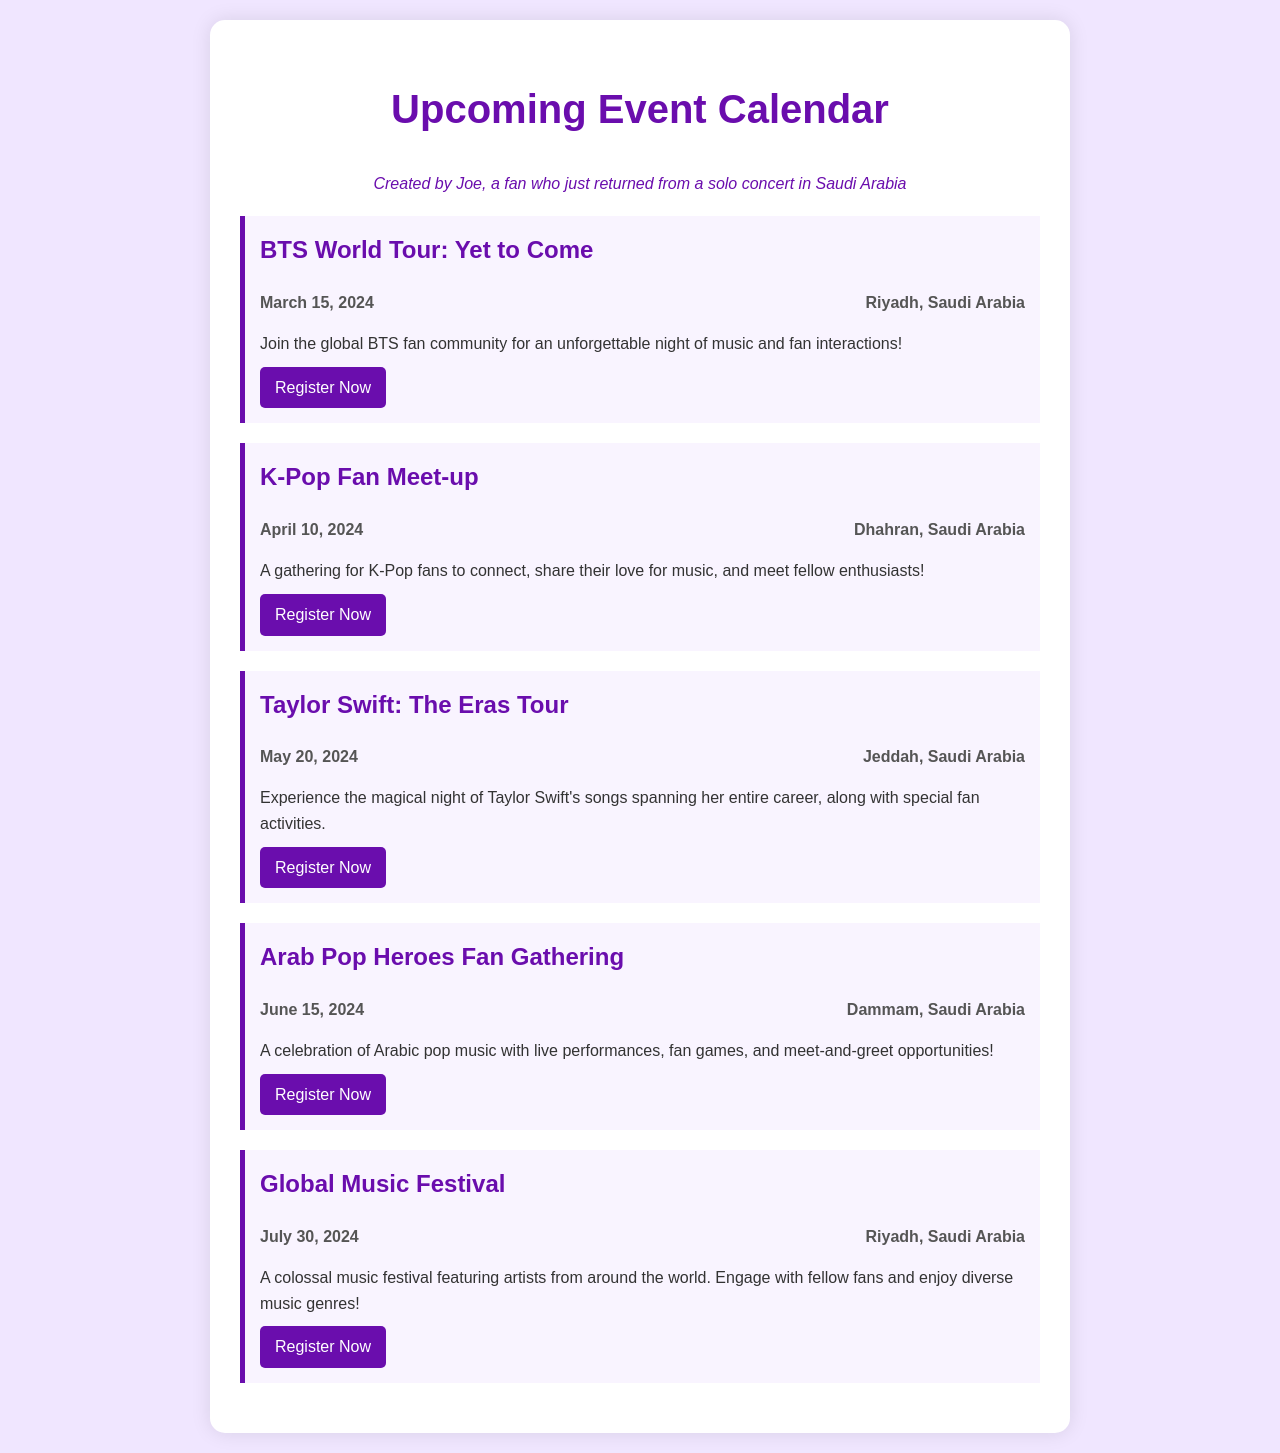What is the title of the first event? The first event listed is "BTS World Tour: Yet to Come."
Answer: BTS World Tour: Yet to Come When is Taylor Swift's concert scheduled? The scheduled date for Taylor Swift's concert is May 20, 2024.
Answer: May 20, 2024 Where will the K-Pop Fan Meet-up take place? The location for the K-Pop Fan Meet-up is Dhahran, Saudi Arabia.
Answer: Dhahran, Saudi Arabia How many days are there until the Global Music Festival? The Global Music Festival is on July 30, 2024, and depending on the current date, the number of days can be calculated.
Answer: N/A (this would require today's date) What is the main theme of the Arab Pop Heroes Fan Gathering? The main theme is a celebration of Arabic pop music with activities.
Answer: Arabic pop music Which event takes place in Jeddah? The event in Jeddah is "Taylor Swift: The Eras Tour."
Answer: Taylor Swift: The Eras Tour How many events are listed in total? There are five events listed in the document.
Answer: 5 Which event includes live performances and meet-and-greet opportunities? The event with live performances and meet-and-greet opportunities is "Arab Pop Heroes Fan Gathering."
Answer: Arab Pop Heroes Fan Gathering What is the common location for the two events in Riyadh? The common location for the two events is Riyadh, Saudi Arabia.
Answer: Riyadh, Saudi Arabia 